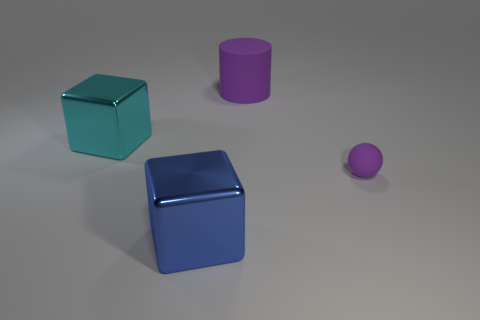Add 1 large yellow metal things. How many objects exist? 5 Subtract all cylinders. How many objects are left? 3 Subtract all matte spheres. Subtract all blue metallic objects. How many objects are left? 2 Add 3 big purple cylinders. How many big purple cylinders are left? 4 Add 2 small brown metallic objects. How many small brown metallic objects exist? 2 Subtract 0 brown cylinders. How many objects are left? 4 